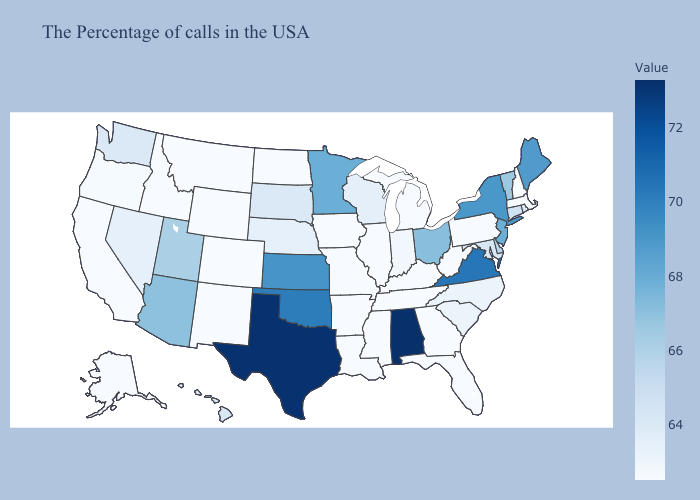Does Florida have a higher value than Texas?
Short answer required. No. Does North Dakota have the lowest value in the USA?
Answer briefly. Yes. Does Alabama have the highest value in the USA?
Write a very short answer. Yes. Does the map have missing data?
Keep it brief. No. 